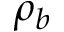Convert formula to latex. <formula><loc_0><loc_0><loc_500><loc_500>\rho _ { b }</formula> 